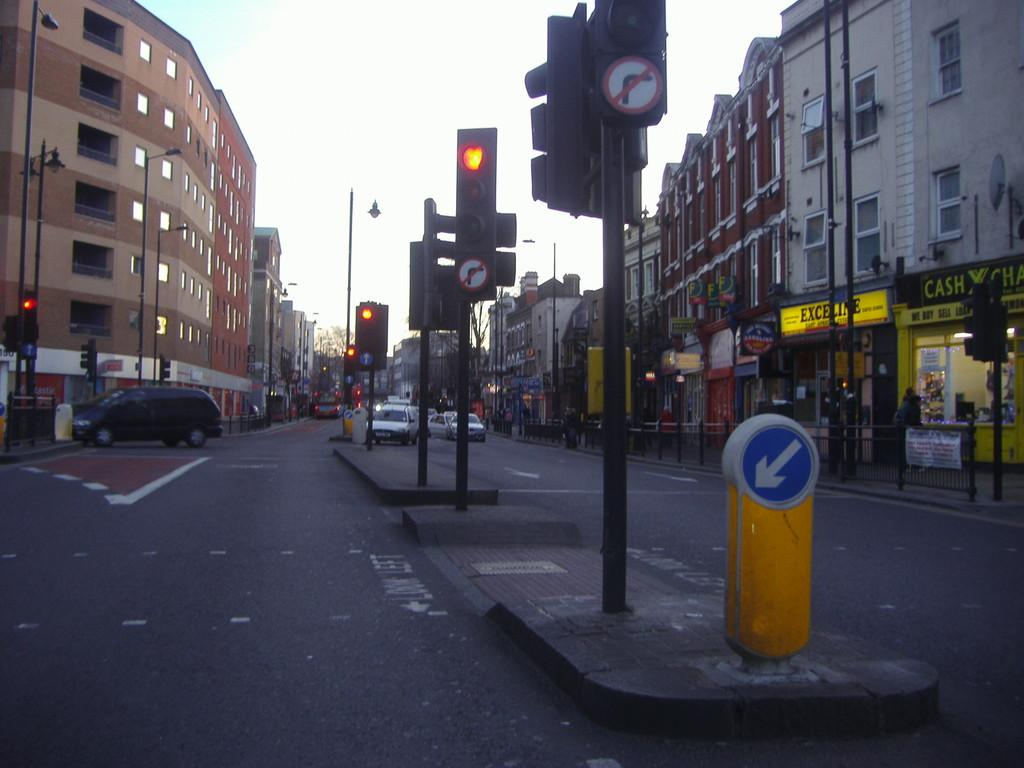<image>
Create a compact narrative representing the image presented. A cross walk that instructs pedestrians to look left when crossing. 